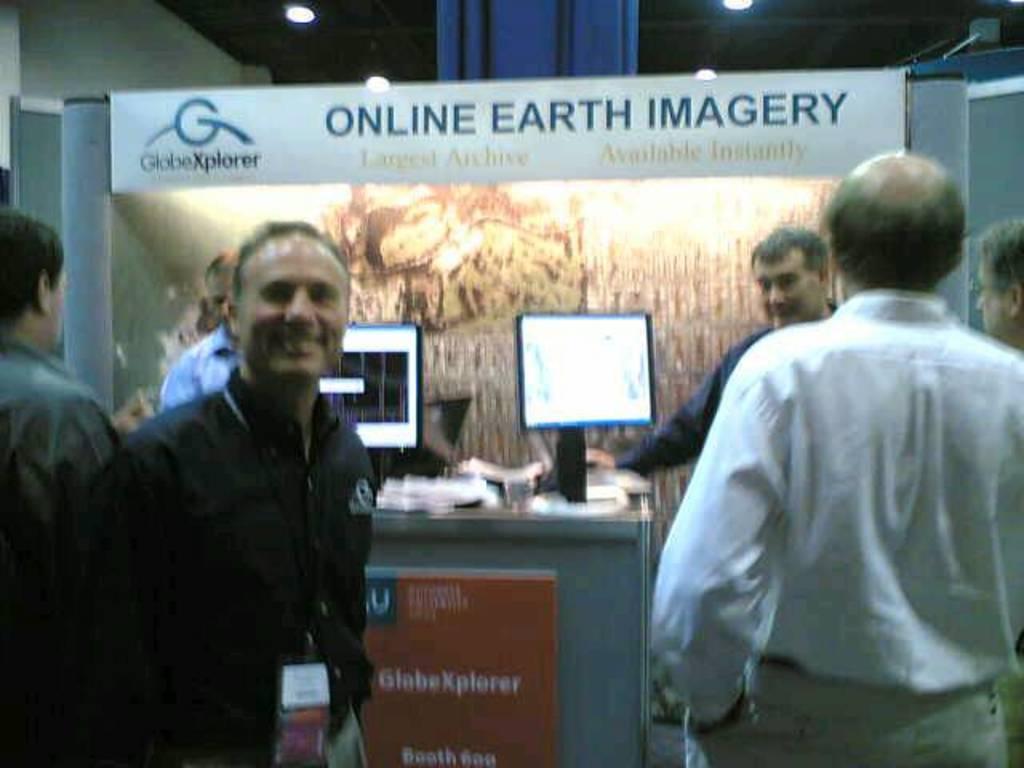In one or two sentences, can you explain what this image depicts? In this image we can see there are persons standing. And there is a table, on the table there is a system, papers, board and some objects. At the top there is a ceiling with lights. And there is a board attached to pole. 